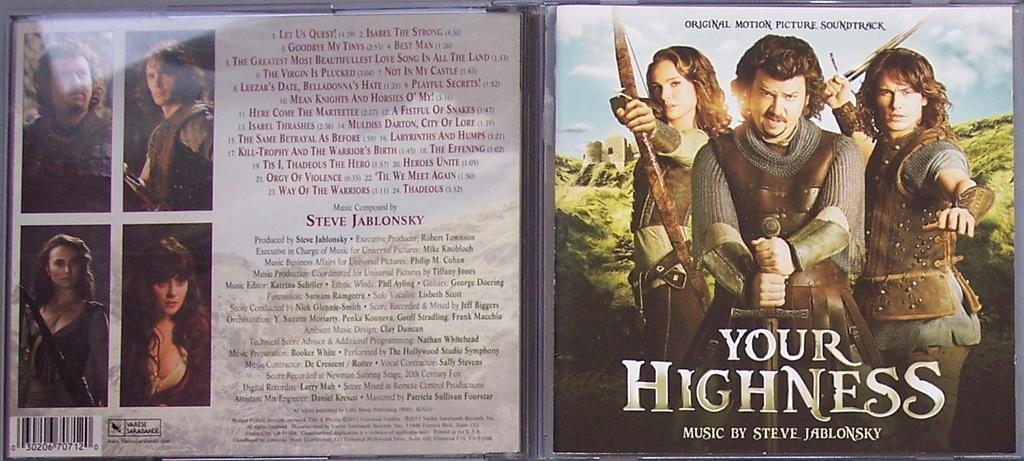<image>
Give a short and clear explanation of the subsequent image. a cd cover for 'your highness' music by steve jablonsky 